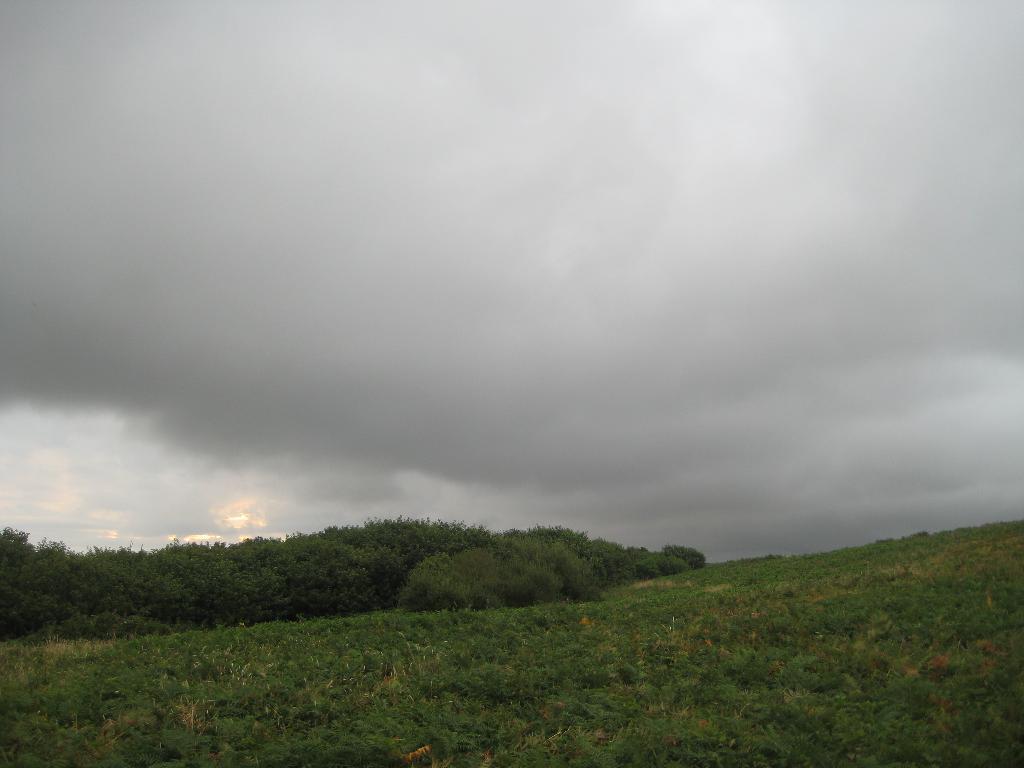Can you describe this image briefly? In this image, we can see some trees and plants. There are clouds in the sky. 